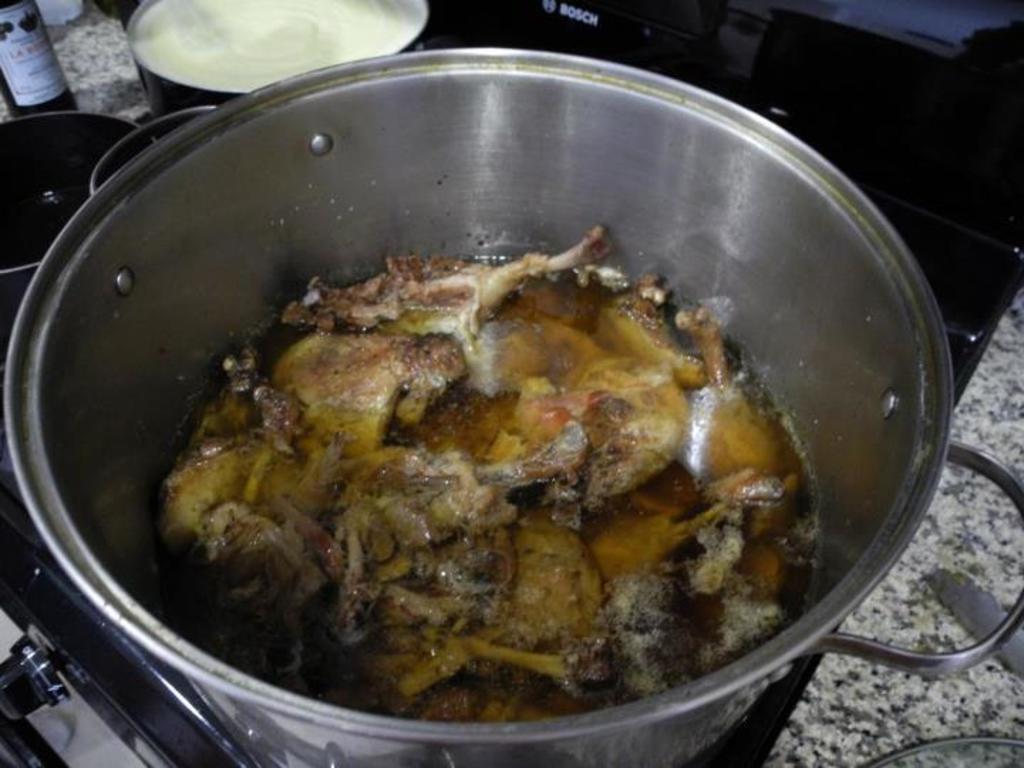Could you give a brief overview of what you see in this image? At the bottom of the image we can see a stove. There is a vessel containing meat placed on the stove. There are bowls and we can see a bottle placed on the counter top. 